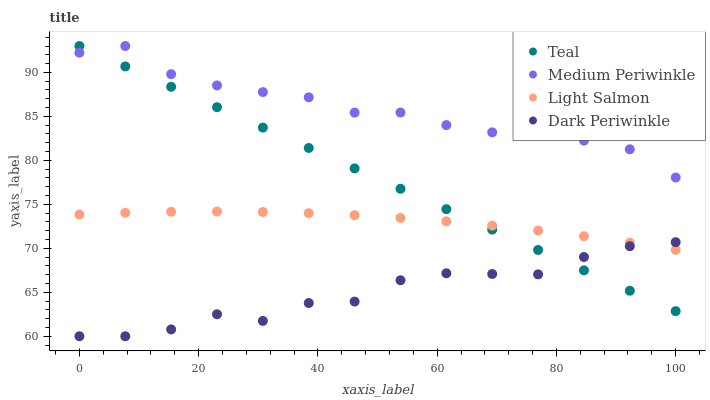Does Dark Periwinkle have the minimum area under the curve?
Answer yes or no. Yes. Does Medium Periwinkle have the maximum area under the curve?
Answer yes or no. Yes. Does Medium Periwinkle have the minimum area under the curve?
Answer yes or no. No. Does Dark Periwinkle have the maximum area under the curve?
Answer yes or no. No. Is Teal the smoothest?
Answer yes or no. Yes. Is Dark Periwinkle the roughest?
Answer yes or no. Yes. Is Medium Periwinkle the smoothest?
Answer yes or no. No. Is Medium Periwinkle the roughest?
Answer yes or no. No. Does Dark Periwinkle have the lowest value?
Answer yes or no. Yes. Does Medium Periwinkle have the lowest value?
Answer yes or no. No. Does Teal have the highest value?
Answer yes or no. Yes. Does Dark Periwinkle have the highest value?
Answer yes or no. No. Is Light Salmon less than Medium Periwinkle?
Answer yes or no. Yes. Is Medium Periwinkle greater than Dark Periwinkle?
Answer yes or no. Yes. Does Teal intersect Light Salmon?
Answer yes or no. Yes. Is Teal less than Light Salmon?
Answer yes or no. No. Is Teal greater than Light Salmon?
Answer yes or no. No. Does Light Salmon intersect Medium Periwinkle?
Answer yes or no. No. 